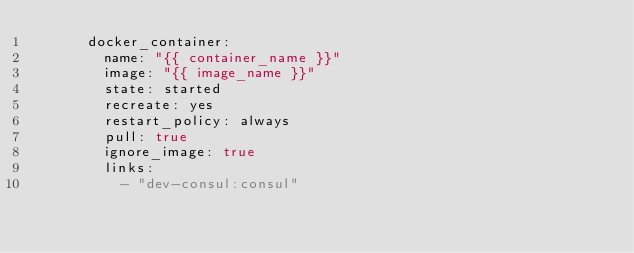Convert code to text. <code><loc_0><loc_0><loc_500><loc_500><_YAML_>      docker_container:
        name: "{{ container_name }}"
        image: "{{ image_name }}"
        state: started
        recreate: yes
        restart_policy: always
        pull: true
        ignore_image: true
        links:
          - "dev-consul:consul"
</code> 